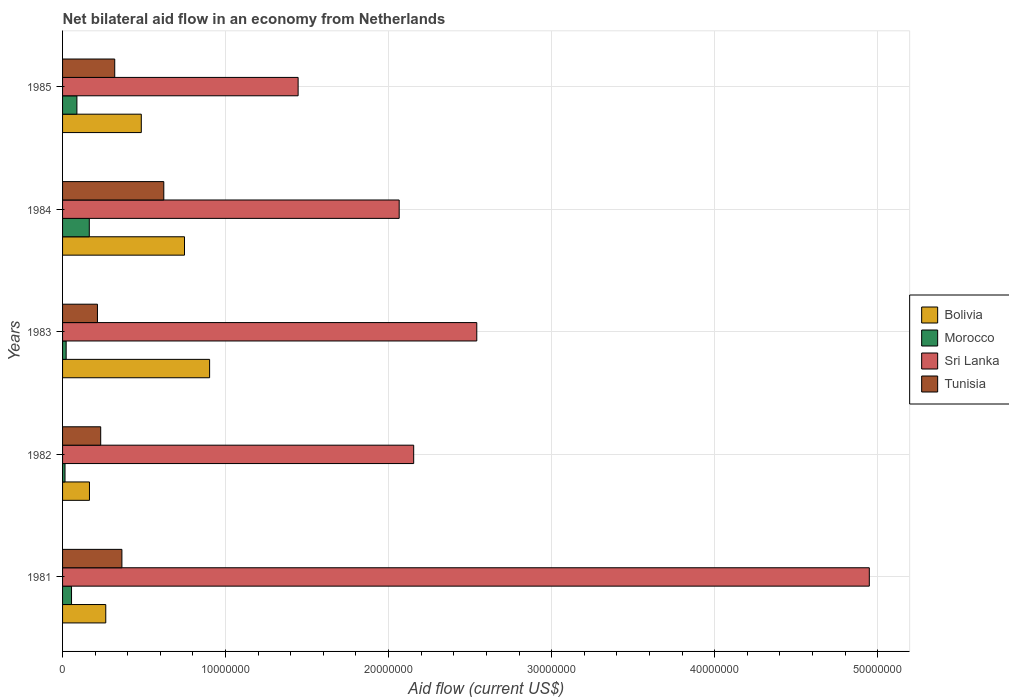How many different coloured bars are there?
Your answer should be very brief. 4. How many groups of bars are there?
Your answer should be very brief. 5. Are the number of bars on each tick of the Y-axis equal?
Give a very brief answer. Yes. How many bars are there on the 1st tick from the top?
Provide a short and direct response. 4. What is the label of the 2nd group of bars from the top?
Offer a terse response. 1984. In how many cases, is the number of bars for a given year not equal to the number of legend labels?
Provide a short and direct response. 0. What is the net bilateral aid flow in Bolivia in 1985?
Ensure brevity in your answer.  4.83e+06. Across all years, what is the maximum net bilateral aid flow in Tunisia?
Provide a succinct answer. 6.21e+06. Across all years, what is the minimum net bilateral aid flow in Sri Lanka?
Provide a short and direct response. 1.44e+07. In which year was the net bilateral aid flow in Morocco minimum?
Offer a terse response. 1982. What is the total net bilateral aid flow in Tunisia in the graph?
Your answer should be compact. 1.75e+07. What is the difference between the net bilateral aid flow in Morocco in 1981 and that in 1982?
Your answer should be very brief. 4.00e+05. What is the difference between the net bilateral aid flow in Sri Lanka in 1985 and the net bilateral aid flow in Bolivia in 1982?
Your answer should be very brief. 1.28e+07. What is the average net bilateral aid flow in Tunisia per year?
Keep it short and to the point. 3.51e+06. In the year 1982, what is the difference between the net bilateral aid flow in Morocco and net bilateral aid flow in Tunisia?
Your answer should be very brief. -2.19e+06. What is the ratio of the net bilateral aid flow in Morocco in 1982 to that in 1984?
Ensure brevity in your answer.  0.09. Is the net bilateral aid flow in Sri Lanka in 1982 less than that in 1983?
Provide a short and direct response. Yes. Is the difference between the net bilateral aid flow in Morocco in 1983 and 1985 greater than the difference between the net bilateral aid flow in Tunisia in 1983 and 1985?
Offer a terse response. Yes. What is the difference between the highest and the second highest net bilateral aid flow in Sri Lanka?
Give a very brief answer. 2.41e+07. What is the difference between the highest and the lowest net bilateral aid flow in Sri Lanka?
Give a very brief answer. 3.50e+07. Is it the case that in every year, the sum of the net bilateral aid flow in Bolivia and net bilateral aid flow in Tunisia is greater than the sum of net bilateral aid flow in Morocco and net bilateral aid flow in Sri Lanka?
Keep it short and to the point. No. What does the 4th bar from the top in 1981 represents?
Offer a very short reply. Bolivia. What does the 4th bar from the bottom in 1982 represents?
Your answer should be compact. Tunisia. Is it the case that in every year, the sum of the net bilateral aid flow in Bolivia and net bilateral aid flow in Tunisia is greater than the net bilateral aid flow in Morocco?
Offer a terse response. Yes. Are all the bars in the graph horizontal?
Your response must be concise. Yes. How many years are there in the graph?
Offer a very short reply. 5. Does the graph contain any zero values?
Provide a short and direct response. No. How many legend labels are there?
Make the answer very short. 4. How are the legend labels stacked?
Your answer should be compact. Vertical. What is the title of the graph?
Make the answer very short. Net bilateral aid flow in an economy from Netherlands. Does "Zimbabwe" appear as one of the legend labels in the graph?
Your answer should be compact. No. What is the label or title of the Y-axis?
Provide a short and direct response. Years. What is the Aid flow (current US$) of Bolivia in 1981?
Your answer should be compact. 2.65e+06. What is the Aid flow (current US$) of Morocco in 1981?
Offer a very short reply. 5.50e+05. What is the Aid flow (current US$) in Sri Lanka in 1981?
Your answer should be compact. 4.95e+07. What is the Aid flow (current US$) in Tunisia in 1981?
Provide a short and direct response. 3.64e+06. What is the Aid flow (current US$) in Bolivia in 1982?
Make the answer very short. 1.65e+06. What is the Aid flow (current US$) of Sri Lanka in 1982?
Provide a short and direct response. 2.15e+07. What is the Aid flow (current US$) of Tunisia in 1982?
Your response must be concise. 2.34e+06. What is the Aid flow (current US$) of Bolivia in 1983?
Keep it short and to the point. 9.02e+06. What is the Aid flow (current US$) of Morocco in 1983?
Provide a short and direct response. 2.20e+05. What is the Aid flow (current US$) in Sri Lanka in 1983?
Give a very brief answer. 2.54e+07. What is the Aid flow (current US$) in Tunisia in 1983?
Provide a succinct answer. 2.14e+06. What is the Aid flow (current US$) in Bolivia in 1984?
Offer a very short reply. 7.48e+06. What is the Aid flow (current US$) in Morocco in 1984?
Provide a succinct answer. 1.64e+06. What is the Aid flow (current US$) of Sri Lanka in 1984?
Offer a terse response. 2.06e+07. What is the Aid flow (current US$) in Tunisia in 1984?
Provide a succinct answer. 6.21e+06. What is the Aid flow (current US$) of Bolivia in 1985?
Provide a succinct answer. 4.83e+06. What is the Aid flow (current US$) in Morocco in 1985?
Make the answer very short. 8.80e+05. What is the Aid flow (current US$) of Sri Lanka in 1985?
Give a very brief answer. 1.44e+07. What is the Aid flow (current US$) of Tunisia in 1985?
Give a very brief answer. 3.20e+06. Across all years, what is the maximum Aid flow (current US$) of Bolivia?
Offer a very short reply. 9.02e+06. Across all years, what is the maximum Aid flow (current US$) in Morocco?
Provide a short and direct response. 1.64e+06. Across all years, what is the maximum Aid flow (current US$) in Sri Lanka?
Your response must be concise. 4.95e+07. Across all years, what is the maximum Aid flow (current US$) of Tunisia?
Ensure brevity in your answer.  6.21e+06. Across all years, what is the minimum Aid flow (current US$) of Bolivia?
Offer a terse response. 1.65e+06. Across all years, what is the minimum Aid flow (current US$) of Morocco?
Offer a terse response. 1.50e+05. Across all years, what is the minimum Aid flow (current US$) of Sri Lanka?
Offer a very short reply. 1.44e+07. Across all years, what is the minimum Aid flow (current US$) of Tunisia?
Ensure brevity in your answer.  2.14e+06. What is the total Aid flow (current US$) of Bolivia in the graph?
Your answer should be compact. 2.56e+07. What is the total Aid flow (current US$) in Morocco in the graph?
Give a very brief answer. 3.44e+06. What is the total Aid flow (current US$) of Sri Lanka in the graph?
Provide a succinct answer. 1.32e+08. What is the total Aid flow (current US$) in Tunisia in the graph?
Offer a terse response. 1.75e+07. What is the difference between the Aid flow (current US$) of Sri Lanka in 1981 and that in 1982?
Offer a terse response. 2.80e+07. What is the difference between the Aid flow (current US$) of Tunisia in 1981 and that in 1982?
Provide a short and direct response. 1.30e+06. What is the difference between the Aid flow (current US$) of Bolivia in 1981 and that in 1983?
Offer a terse response. -6.37e+06. What is the difference between the Aid flow (current US$) in Sri Lanka in 1981 and that in 1983?
Ensure brevity in your answer.  2.41e+07. What is the difference between the Aid flow (current US$) in Tunisia in 1981 and that in 1983?
Your response must be concise. 1.50e+06. What is the difference between the Aid flow (current US$) of Bolivia in 1981 and that in 1984?
Your answer should be compact. -4.83e+06. What is the difference between the Aid flow (current US$) in Morocco in 1981 and that in 1984?
Your response must be concise. -1.09e+06. What is the difference between the Aid flow (current US$) in Sri Lanka in 1981 and that in 1984?
Give a very brief answer. 2.88e+07. What is the difference between the Aid flow (current US$) in Tunisia in 1981 and that in 1984?
Provide a short and direct response. -2.57e+06. What is the difference between the Aid flow (current US$) of Bolivia in 1981 and that in 1985?
Keep it short and to the point. -2.18e+06. What is the difference between the Aid flow (current US$) in Morocco in 1981 and that in 1985?
Provide a succinct answer. -3.30e+05. What is the difference between the Aid flow (current US$) of Sri Lanka in 1981 and that in 1985?
Provide a short and direct response. 3.50e+07. What is the difference between the Aid flow (current US$) of Bolivia in 1982 and that in 1983?
Your answer should be compact. -7.37e+06. What is the difference between the Aid flow (current US$) in Morocco in 1982 and that in 1983?
Ensure brevity in your answer.  -7.00e+04. What is the difference between the Aid flow (current US$) of Sri Lanka in 1982 and that in 1983?
Give a very brief answer. -3.87e+06. What is the difference between the Aid flow (current US$) in Bolivia in 1982 and that in 1984?
Make the answer very short. -5.83e+06. What is the difference between the Aid flow (current US$) of Morocco in 1982 and that in 1984?
Provide a succinct answer. -1.49e+06. What is the difference between the Aid flow (current US$) in Sri Lanka in 1982 and that in 1984?
Provide a succinct answer. 8.90e+05. What is the difference between the Aid flow (current US$) in Tunisia in 1982 and that in 1984?
Provide a succinct answer. -3.87e+06. What is the difference between the Aid flow (current US$) in Bolivia in 1982 and that in 1985?
Your answer should be compact. -3.18e+06. What is the difference between the Aid flow (current US$) of Morocco in 1982 and that in 1985?
Your answer should be compact. -7.30e+05. What is the difference between the Aid flow (current US$) in Sri Lanka in 1982 and that in 1985?
Your answer should be compact. 7.09e+06. What is the difference between the Aid flow (current US$) of Tunisia in 1982 and that in 1985?
Keep it short and to the point. -8.60e+05. What is the difference between the Aid flow (current US$) of Bolivia in 1983 and that in 1984?
Ensure brevity in your answer.  1.54e+06. What is the difference between the Aid flow (current US$) in Morocco in 1983 and that in 1984?
Provide a succinct answer. -1.42e+06. What is the difference between the Aid flow (current US$) in Sri Lanka in 1983 and that in 1984?
Provide a succinct answer. 4.76e+06. What is the difference between the Aid flow (current US$) in Tunisia in 1983 and that in 1984?
Your answer should be very brief. -4.07e+06. What is the difference between the Aid flow (current US$) of Bolivia in 1983 and that in 1985?
Offer a very short reply. 4.19e+06. What is the difference between the Aid flow (current US$) in Morocco in 1983 and that in 1985?
Your answer should be compact. -6.60e+05. What is the difference between the Aid flow (current US$) in Sri Lanka in 1983 and that in 1985?
Ensure brevity in your answer.  1.10e+07. What is the difference between the Aid flow (current US$) of Tunisia in 1983 and that in 1985?
Give a very brief answer. -1.06e+06. What is the difference between the Aid flow (current US$) of Bolivia in 1984 and that in 1985?
Offer a terse response. 2.65e+06. What is the difference between the Aid flow (current US$) of Morocco in 1984 and that in 1985?
Keep it short and to the point. 7.60e+05. What is the difference between the Aid flow (current US$) in Sri Lanka in 1984 and that in 1985?
Keep it short and to the point. 6.20e+06. What is the difference between the Aid flow (current US$) in Tunisia in 1984 and that in 1985?
Give a very brief answer. 3.01e+06. What is the difference between the Aid flow (current US$) in Bolivia in 1981 and the Aid flow (current US$) in Morocco in 1982?
Offer a very short reply. 2.50e+06. What is the difference between the Aid flow (current US$) of Bolivia in 1981 and the Aid flow (current US$) of Sri Lanka in 1982?
Provide a succinct answer. -1.89e+07. What is the difference between the Aid flow (current US$) of Bolivia in 1981 and the Aid flow (current US$) of Tunisia in 1982?
Keep it short and to the point. 3.10e+05. What is the difference between the Aid flow (current US$) of Morocco in 1981 and the Aid flow (current US$) of Sri Lanka in 1982?
Provide a short and direct response. -2.10e+07. What is the difference between the Aid flow (current US$) of Morocco in 1981 and the Aid flow (current US$) of Tunisia in 1982?
Your answer should be very brief. -1.79e+06. What is the difference between the Aid flow (current US$) in Sri Lanka in 1981 and the Aid flow (current US$) in Tunisia in 1982?
Ensure brevity in your answer.  4.72e+07. What is the difference between the Aid flow (current US$) in Bolivia in 1981 and the Aid flow (current US$) in Morocco in 1983?
Provide a succinct answer. 2.43e+06. What is the difference between the Aid flow (current US$) in Bolivia in 1981 and the Aid flow (current US$) in Sri Lanka in 1983?
Give a very brief answer. -2.28e+07. What is the difference between the Aid flow (current US$) in Bolivia in 1981 and the Aid flow (current US$) in Tunisia in 1983?
Make the answer very short. 5.10e+05. What is the difference between the Aid flow (current US$) in Morocco in 1981 and the Aid flow (current US$) in Sri Lanka in 1983?
Give a very brief answer. -2.49e+07. What is the difference between the Aid flow (current US$) of Morocco in 1981 and the Aid flow (current US$) of Tunisia in 1983?
Give a very brief answer. -1.59e+06. What is the difference between the Aid flow (current US$) of Sri Lanka in 1981 and the Aid flow (current US$) of Tunisia in 1983?
Offer a terse response. 4.74e+07. What is the difference between the Aid flow (current US$) in Bolivia in 1981 and the Aid flow (current US$) in Morocco in 1984?
Make the answer very short. 1.01e+06. What is the difference between the Aid flow (current US$) of Bolivia in 1981 and the Aid flow (current US$) of Sri Lanka in 1984?
Offer a very short reply. -1.80e+07. What is the difference between the Aid flow (current US$) of Bolivia in 1981 and the Aid flow (current US$) of Tunisia in 1984?
Provide a succinct answer. -3.56e+06. What is the difference between the Aid flow (current US$) in Morocco in 1981 and the Aid flow (current US$) in Sri Lanka in 1984?
Provide a succinct answer. -2.01e+07. What is the difference between the Aid flow (current US$) in Morocco in 1981 and the Aid flow (current US$) in Tunisia in 1984?
Offer a terse response. -5.66e+06. What is the difference between the Aid flow (current US$) in Sri Lanka in 1981 and the Aid flow (current US$) in Tunisia in 1984?
Your response must be concise. 4.33e+07. What is the difference between the Aid flow (current US$) in Bolivia in 1981 and the Aid flow (current US$) in Morocco in 1985?
Offer a terse response. 1.77e+06. What is the difference between the Aid flow (current US$) in Bolivia in 1981 and the Aid flow (current US$) in Sri Lanka in 1985?
Your answer should be very brief. -1.18e+07. What is the difference between the Aid flow (current US$) of Bolivia in 1981 and the Aid flow (current US$) of Tunisia in 1985?
Provide a short and direct response. -5.50e+05. What is the difference between the Aid flow (current US$) of Morocco in 1981 and the Aid flow (current US$) of Sri Lanka in 1985?
Keep it short and to the point. -1.39e+07. What is the difference between the Aid flow (current US$) in Morocco in 1981 and the Aid flow (current US$) in Tunisia in 1985?
Provide a succinct answer. -2.65e+06. What is the difference between the Aid flow (current US$) in Sri Lanka in 1981 and the Aid flow (current US$) in Tunisia in 1985?
Provide a succinct answer. 4.63e+07. What is the difference between the Aid flow (current US$) of Bolivia in 1982 and the Aid flow (current US$) of Morocco in 1983?
Your answer should be very brief. 1.43e+06. What is the difference between the Aid flow (current US$) of Bolivia in 1982 and the Aid flow (current US$) of Sri Lanka in 1983?
Your response must be concise. -2.38e+07. What is the difference between the Aid flow (current US$) in Bolivia in 1982 and the Aid flow (current US$) in Tunisia in 1983?
Keep it short and to the point. -4.90e+05. What is the difference between the Aid flow (current US$) of Morocco in 1982 and the Aid flow (current US$) of Sri Lanka in 1983?
Your answer should be very brief. -2.53e+07. What is the difference between the Aid flow (current US$) in Morocco in 1982 and the Aid flow (current US$) in Tunisia in 1983?
Your answer should be compact. -1.99e+06. What is the difference between the Aid flow (current US$) in Sri Lanka in 1982 and the Aid flow (current US$) in Tunisia in 1983?
Your answer should be very brief. 1.94e+07. What is the difference between the Aid flow (current US$) of Bolivia in 1982 and the Aid flow (current US$) of Sri Lanka in 1984?
Make the answer very short. -1.90e+07. What is the difference between the Aid flow (current US$) in Bolivia in 1982 and the Aid flow (current US$) in Tunisia in 1984?
Your answer should be very brief. -4.56e+06. What is the difference between the Aid flow (current US$) of Morocco in 1982 and the Aid flow (current US$) of Sri Lanka in 1984?
Keep it short and to the point. -2.05e+07. What is the difference between the Aid flow (current US$) of Morocco in 1982 and the Aid flow (current US$) of Tunisia in 1984?
Make the answer very short. -6.06e+06. What is the difference between the Aid flow (current US$) in Sri Lanka in 1982 and the Aid flow (current US$) in Tunisia in 1984?
Ensure brevity in your answer.  1.53e+07. What is the difference between the Aid flow (current US$) in Bolivia in 1982 and the Aid flow (current US$) in Morocco in 1985?
Provide a short and direct response. 7.70e+05. What is the difference between the Aid flow (current US$) of Bolivia in 1982 and the Aid flow (current US$) of Sri Lanka in 1985?
Make the answer very short. -1.28e+07. What is the difference between the Aid flow (current US$) in Bolivia in 1982 and the Aid flow (current US$) in Tunisia in 1985?
Your answer should be compact. -1.55e+06. What is the difference between the Aid flow (current US$) of Morocco in 1982 and the Aid flow (current US$) of Sri Lanka in 1985?
Give a very brief answer. -1.43e+07. What is the difference between the Aid flow (current US$) of Morocco in 1982 and the Aid flow (current US$) of Tunisia in 1985?
Ensure brevity in your answer.  -3.05e+06. What is the difference between the Aid flow (current US$) of Sri Lanka in 1982 and the Aid flow (current US$) of Tunisia in 1985?
Offer a very short reply. 1.83e+07. What is the difference between the Aid flow (current US$) in Bolivia in 1983 and the Aid flow (current US$) in Morocco in 1984?
Your answer should be compact. 7.38e+06. What is the difference between the Aid flow (current US$) of Bolivia in 1983 and the Aid flow (current US$) of Sri Lanka in 1984?
Your response must be concise. -1.16e+07. What is the difference between the Aid flow (current US$) of Bolivia in 1983 and the Aid flow (current US$) of Tunisia in 1984?
Offer a very short reply. 2.81e+06. What is the difference between the Aid flow (current US$) in Morocco in 1983 and the Aid flow (current US$) in Sri Lanka in 1984?
Make the answer very short. -2.04e+07. What is the difference between the Aid flow (current US$) of Morocco in 1983 and the Aid flow (current US$) of Tunisia in 1984?
Provide a succinct answer. -5.99e+06. What is the difference between the Aid flow (current US$) in Sri Lanka in 1983 and the Aid flow (current US$) in Tunisia in 1984?
Your answer should be very brief. 1.92e+07. What is the difference between the Aid flow (current US$) of Bolivia in 1983 and the Aid flow (current US$) of Morocco in 1985?
Give a very brief answer. 8.14e+06. What is the difference between the Aid flow (current US$) in Bolivia in 1983 and the Aid flow (current US$) in Sri Lanka in 1985?
Offer a very short reply. -5.43e+06. What is the difference between the Aid flow (current US$) of Bolivia in 1983 and the Aid flow (current US$) of Tunisia in 1985?
Make the answer very short. 5.82e+06. What is the difference between the Aid flow (current US$) of Morocco in 1983 and the Aid flow (current US$) of Sri Lanka in 1985?
Give a very brief answer. -1.42e+07. What is the difference between the Aid flow (current US$) in Morocco in 1983 and the Aid flow (current US$) in Tunisia in 1985?
Offer a terse response. -2.98e+06. What is the difference between the Aid flow (current US$) in Sri Lanka in 1983 and the Aid flow (current US$) in Tunisia in 1985?
Offer a terse response. 2.22e+07. What is the difference between the Aid flow (current US$) in Bolivia in 1984 and the Aid flow (current US$) in Morocco in 1985?
Keep it short and to the point. 6.60e+06. What is the difference between the Aid flow (current US$) of Bolivia in 1984 and the Aid flow (current US$) of Sri Lanka in 1985?
Your answer should be compact. -6.97e+06. What is the difference between the Aid flow (current US$) of Bolivia in 1984 and the Aid flow (current US$) of Tunisia in 1985?
Make the answer very short. 4.28e+06. What is the difference between the Aid flow (current US$) in Morocco in 1984 and the Aid flow (current US$) in Sri Lanka in 1985?
Your answer should be very brief. -1.28e+07. What is the difference between the Aid flow (current US$) in Morocco in 1984 and the Aid flow (current US$) in Tunisia in 1985?
Offer a terse response. -1.56e+06. What is the difference between the Aid flow (current US$) in Sri Lanka in 1984 and the Aid flow (current US$) in Tunisia in 1985?
Give a very brief answer. 1.74e+07. What is the average Aid flow (current US$) of Bolivia per year?
Give a very brief answer. 5.13e+06. What is the average Aid flow (current US$) of Morocco per year?
Keep it short and to the point. 6.88e+05. What is the average Aid flow (current US$) of Sri Lanka per year?
Your answer should be very brief. 2.63e+07. What is the average Aid flow (current US$) of Tunisia per year?
Provide a succinct answer. 3.51e+06. In the year 1981, what is the difference between the Aid flow (current US$) in Bolivia and Aid flow (current US$) in Morocco?
Your answer should be very brief. 2.10e+06. In the year 1981, what is the difference between the Aid flow (current US$) in Bolivia and Aid flow (current US$) in Sri Lanka?
Your answer should be compact. -4.68e+07. In the year 1981, what is the difference between the Aid flow (current US$) of Bolivia and Aid flow (current US$) of Tunisia?
Offer a terse response. -9.90e+05. In the year 1981, what is the difference between the Aid flow (current US$) in Morocco and Aid flow (current US$) in Sri Lanka?
Keep it short and to the point. -4.89e+07. In the year 1981, what is the difference between the Aid flow (current US$) in Morocco and Aid flow (current US$) in Tunisia?
Your answer should be compact. -3.09e+06. In the year 1981, what is the difference between the Aid flow (current US$) of Sri Lanka and Aid flow (current US$) of Tunisia?
Provide a short and direct response. 4.58e+07. In the year 1982, what is the difference between the Aid flow (current US$) in Bolivia and Aid flow (current US$) in Morocco?
Keep it short and to the point. 1.50e+06. In the year 1982, what is the difference between the Aid flow (current US$) in Bolivia and Aid flow (current US$) in Sri Lanka?
Your response must be concise. -1.99e+07. In the year 1982, what is the difference between the Aid flow (current US$) of Bolivia and Aid flow (current US$) of Tunisia?
Provide a succinct answer. -6.90e+05. In the year 1982, what is the difference between the Aid flow (current US$) of Morocco and Aid flow (current US$) of Sri Lanka?
Provide a short and direct response. -2.14e+07. In the year 1982, what is the difference between the Aid flow (current US$) in Morocco and Aid flow (current US$) in Tunisia?
Offer a very short reply. -2.19e+06. In the year 1982, what is the difference between the Aid flow (current US$) in Sri Lanka and Aid flow (current US$) in Tunisia?
Offer a very short reply. 1.92e+07. In the year 1983, what is the difference between the Aid flow (current US$) in Bolivia and Aid flow (current US$) in Morocco?
Ensure brevity in your answer.  8.80e+06. In the year 1983, what is the difference between the Aid flow (current US$) of Bolivia and Aid flow (current US$) of Sri Lanka?
Your answer should be very brief. -1.64e+07. In the year 1983, what is the difference between the Aid flow (current US$) of Bolivia and Aid flow (current US$) of Tunisia?
Provide a succinct answer. 6.88e+06. In the year 1983, what is the difference between the Aid flow (current US$) of Morocco and Aid flow (current US$) of Sri Lanka?
Provide a short and direct response. -2.52e+07. In the year 1983, what is the difference between the Aid flow (current US$) in Morocco and Aid flow (current US$) in Tunisia?
Offer a terse response. -1.92e+06. In the year 1983, what is the difference between the Aid flow (current US$) in Sri Lanka and Aid flow (current US$) in Tunisia?
Keep it short and to the point. 2.33e+07. In the year 1984, what is the difference between the Aid flow (current US$) in Bolivia and Aid flow (current US$) in Morocco?
Make the answer very short. 5.84e+06. In the year 1984, what is the difference between the Aid flow (current US$) in Bolivia and Aid flow (current US$) in Sri Lanka?
Provide a succinct answer. -1.32e+07. In the year 1984, what is the difference between the Aid flow (current US$) of Bolivia and Aid flow (current US$) of Tunisia?
Your answer should be compact. 1.27e+06. In the year 1984, what is the difference between the Aid flow (current US$) in Morocco and Aid flow (current US$) in Sri Lanka?
Give a very brief answer. -1.90e+07. In the year 1984, what is the difference between the Aid flow (current US$) in Morocco and Aid flow (current US$) in Tunisia?
Your answer should be compact. -4.57e+06. In the year 1984, what is the difference between the Aid flow (current US$) of Sri Lanka and Aid flow (current US$) of Tunisia?
Offer a very short reply. 1.44e+07. In the year 1985, what is the difference between the Aid flow (current US$) in Bolivia and Aid flow (current US$) in Morocco?
Make the answer very short. 3.95e+06. In the year 1985, what is the difference between the Aid flow (current US$) of Bolivia and Aid flow (current US$) of Sri Lanka?
Make the answer very short. -9.62e+06. In the year 1985, what is the difference between the Aid flow (current US$) of Bolivia and Aid flow (current US$) of Tunisia?
Your answer should be very brief. 1.63e+06. In the year 1985, what is the difference between the Aid flow (current US$) of Morocco and Aid flow (current US$) of Sri Lanka?
Provide a succinct answer. -1.36e+07. In the year 1985, what is the difference between the Aid flow (current US$) in Morocco and Aid flow (current US$) in Tunisia?
Provide a succinct answer. -2.32e+06. In the year 1985, what is the difference between the Aid flow (current US$) of Sri Lanka and Aid flow (current US$) of Tunisia?
Provide a succinct answer. 1.12e+07. What is the ratio of the Aid flow (current US$) of Bolivia in 1981 to that in 1982?
Provide a short and direct response. 1.61. What is the ratio of the Aid flow (current US$) in Morocco in 1981 to that in 1982?
Provide a short and direct response. 3.67. What is the ratio of the Aid flow (current US$) in Sri Lanka in 1981 to that in 1982?
Keep it short and to the point. 2.3. What is the ratio of the Aid flow (current US$) in Tunisia in 1981 to that in 1982?
Your response must be concise. 1.56. What is the ratio of the Aid flow (current US$) in Bolivia in 1981 to that in 1983?
Give a very brief answer. 0.29. What is the ratio of the Aid flow (current US$) of Sri Lanka in 1981 to that in 1983?
Ensure brevity in your answer.  1.95. What is the ratio of the Aid flow (current US$) of Tunisia in 1981 to that in 1983?
Keep it short and to the point. 1.7. What is the ratio of the Aid flow (current US$) of Bolivia in 1981 to that in 1984?
Keep it short and to the point. 0.35. What is the ratio of the Aid flow (current US$) of Morocco in 1981 to that in 1984?
Your response must be concise. 0.34. What is the ratio of the Aid flow (current US$) in Sri Lanka in 1981 to that in 1984?
Make the answer very short. 2.4. What is the ratio of the Aid flow (current US$) in Tunisia in 1981 to that in 1984?
Your answer should be compact. 0.59. What is the ratio of the Aid flow (current US$) in Bolivia in 1981 to that in 1985?
Provide a succinct answer. 0.55. What is the ratio of the Aid flow (current US$) in Sri Lanka in 1981 to that in 1985?
Provide a succinct answer. 3.42. What is the ratio of the Aid flow (current US$) of Tunisia in 1981 to that in 1985?
Offer a terse response. 1.14. What is the ratio of the Aid flow (current US$) in Bolivia in 1982 to that in 1983?
Give a very brief answer. 0.18. What is the ratio of the Aid flow (current US$) in Morocco in 1982 to that in 1983?
Ensure brevity in your answer.  0.68. What is the ratio of the Aid flow (current US$) of Sri Lanka in 1982 to that in 1983?
Offer a terse response. 0.85. What is the ratio of the Aid flow (current US$) in Tunisia in 1982 to that in 1983?
Offer a terse response. 1.09. What is the ratio of the Aid flow (current US$) in Bolivia in 1982 to that in 1984?
Provide a succinct answer. 0.22. What is the ratio of the Aid flow (current US$) in Morocco in 1982 to that in 1984?
Your answer should be compact. 0.09. What is the ratio of the Aid flow (current US$) of Sri Lanka in 1982 to that in 1984?
Ensure brevity in your answer.  1.04. What is the ratio of the Aid flow (current US$) in Tunisia in 1982 to that in 1984?
Provide a short and direct response. 0.38. What is the ratio of the Aid flow (current US$) in Bolivia in 1982 to that in 1985?
Your answer should be compact. 0.34. What is the ratio of the Aid flow (current US$) in Morocco in 1982 to that in 1985?
Provide a short and direct response. 0.17. What is the ratio of the Aid flow (current US$) in Sri Lanka in 1982 to that in 1985?
Keep it short and to the point. 1.49. What is the ratio of the Aid flow (current US$) of Tunisia in 1982 to that in 1985?
Make the answer very short. 0.73. What is the ratio of the Aid flow (current US$) of Bolivia in 1983 to that in 1984?
Keep it short and to the point. 1.21. What is the ratio of the Aid flow (current US$) in Morocco in 1983 to that in 1984?
Give a very brief answer. 0.13. What is the ratio of the Aid flow (current US$) in Sri Lanka in 1983 to that in 1984?
Ensure brevity in your answer.  1.23. What is the ratio of the Aid flow (current US$) in Tunisia in 1983 to that in 1984?
Provide a succinct answer. 0.34. What is the ratio of the Aid flow (current US$) of Bolivia in 1983 to that in 1985?
Ensure brevity in your answer.  1.87. What is the ratio of the Aid flow (current US$) in Morocco in 1983 to that in 1985?
Offer a terse response. 0.25. What is the ratio of the Aid flow (current US$) of Sri Lanka in 1983 to that in 1985?
Make the answer very short. 1.76. What is the ratio of the Aid flow (current US$) of Tunisia in 1983 to that in 1985?
Your answer should be compact. 0.67. What is the ratio of the Aid flow (current US$) in Bolivia in 1984 to that in 1985?
Give a very brief answer. 1.55. What is the ratio of the Aid flow (current US$) of Morocco in 1984 to that in 1985?
Your answer should be very brief. 1.86. What is the ratio of the Aid flow (current US$) in Sri Lanka in 1984 to that in 1985?
Your answer should be compact. 1.43. What is the ratio of the Aid flow (current US$) in Tunisia in 1984 to that in 1985?
Ensure brevity in your answer.  1.94. What is the difference between the highest and the second highest Aid flow (current US$) of Bolivia?
Ensure brevity in your answer.  1.54e+06. What is the difference between the highest and the second highest Aid flow (current US$) of Morocco?
Provide a short and direct response. 7.60e+05. What is the difference between the highest and the second highest Aid flow (current US$) in Sri Lanka?
Keep it short and to the point. 2.41e+07. What is the difference between the highest and the second highest Aid flow (current US$) in Tunisia?
Ensure brevity in your answer.  2.57e+06. What is the difference between the highest and the lowest Aid flow (current US$) in Bolivia?
Your answer should be compact. 7.37e+06. What is the difference between the highest and the lowest Aid flow (current US$) of Morocco?
Give a very brief answer. 1.49e+06. What is the difference between the highest and the lowest Aid flow (current US$) in Sri Lanka?
Your response must be concise. 3.50e+07. What is the difference between the highest and the lowest Aid flow (current US$) of Tunisia?
Give a very brief answer. 4.07e+06. 